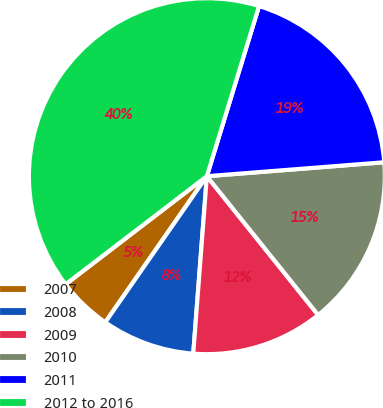<chart> <loc_0><loc_0><loc_500><loc_500><pie_chart><fcel>2007<fcel>2008<fcel>2009<fcel>2010<fcel>2011<fcel>2012 to 2016<nl><fcel>4.93%<fcel>8.45%<fcel>11.97%<fcel>15.49%<fcel>19.01%<fcel>40.13%<nl></chart> 